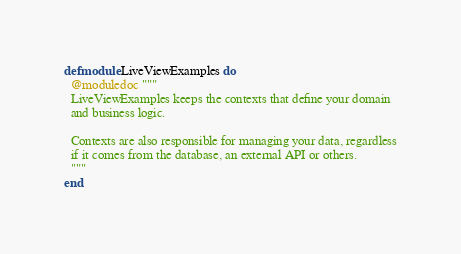<code> <loc_0><loc_0><loc_500><loc_500><_Elixir_>defmodule LiveViewExamples do
  @moduledoc """
  LiveViewExamples keeps the contexts that define your domain
  and business logic.

  Contexts are also responsible for managing your data, regardless
  if it comes from the database, an external API or others.
  """
end
</code> 